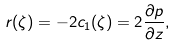<formula> <loc_0><loc_0><loc_500><loc_500>r ( \zeta ) = - 2 c _ { 1 } ( \zeta ) = 2 \frac { \partial p } { \partial z } ,</formula> 